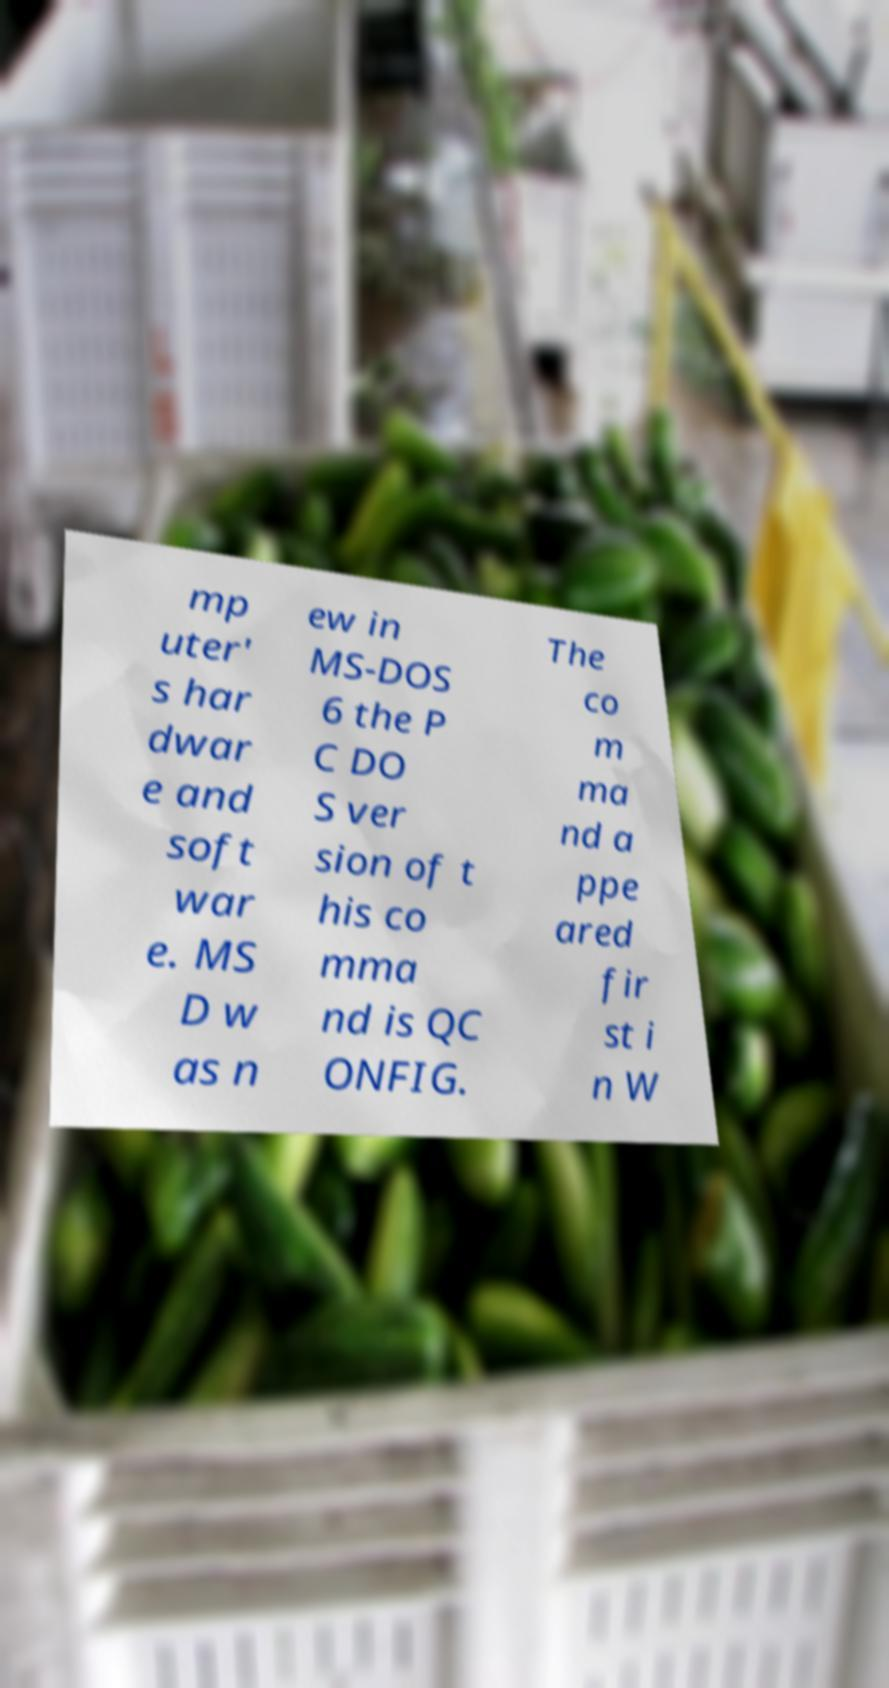Could you extract and type out the text from this image? mp uter' s har dwar e and soft war e. MS D w as n ew in MS-DOS 6 the P C DO S ver sion of t his co mma nd is QC ONFIG. The co m ma nd a ppe ared fir st i n W 